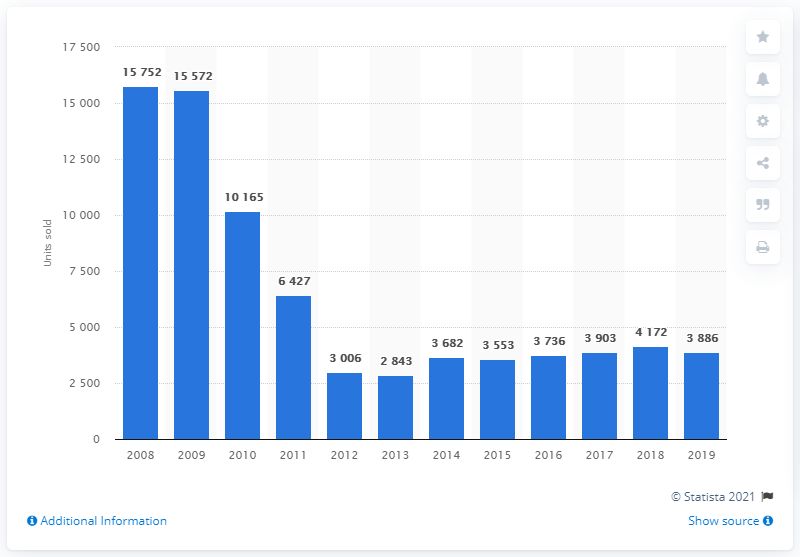Specify some key components in this picture. In 2008, the highest sales volume of Ford vehicles in Greece was 15,752. In 2019, Ford sold a total of 3,886 cars in Greece. 